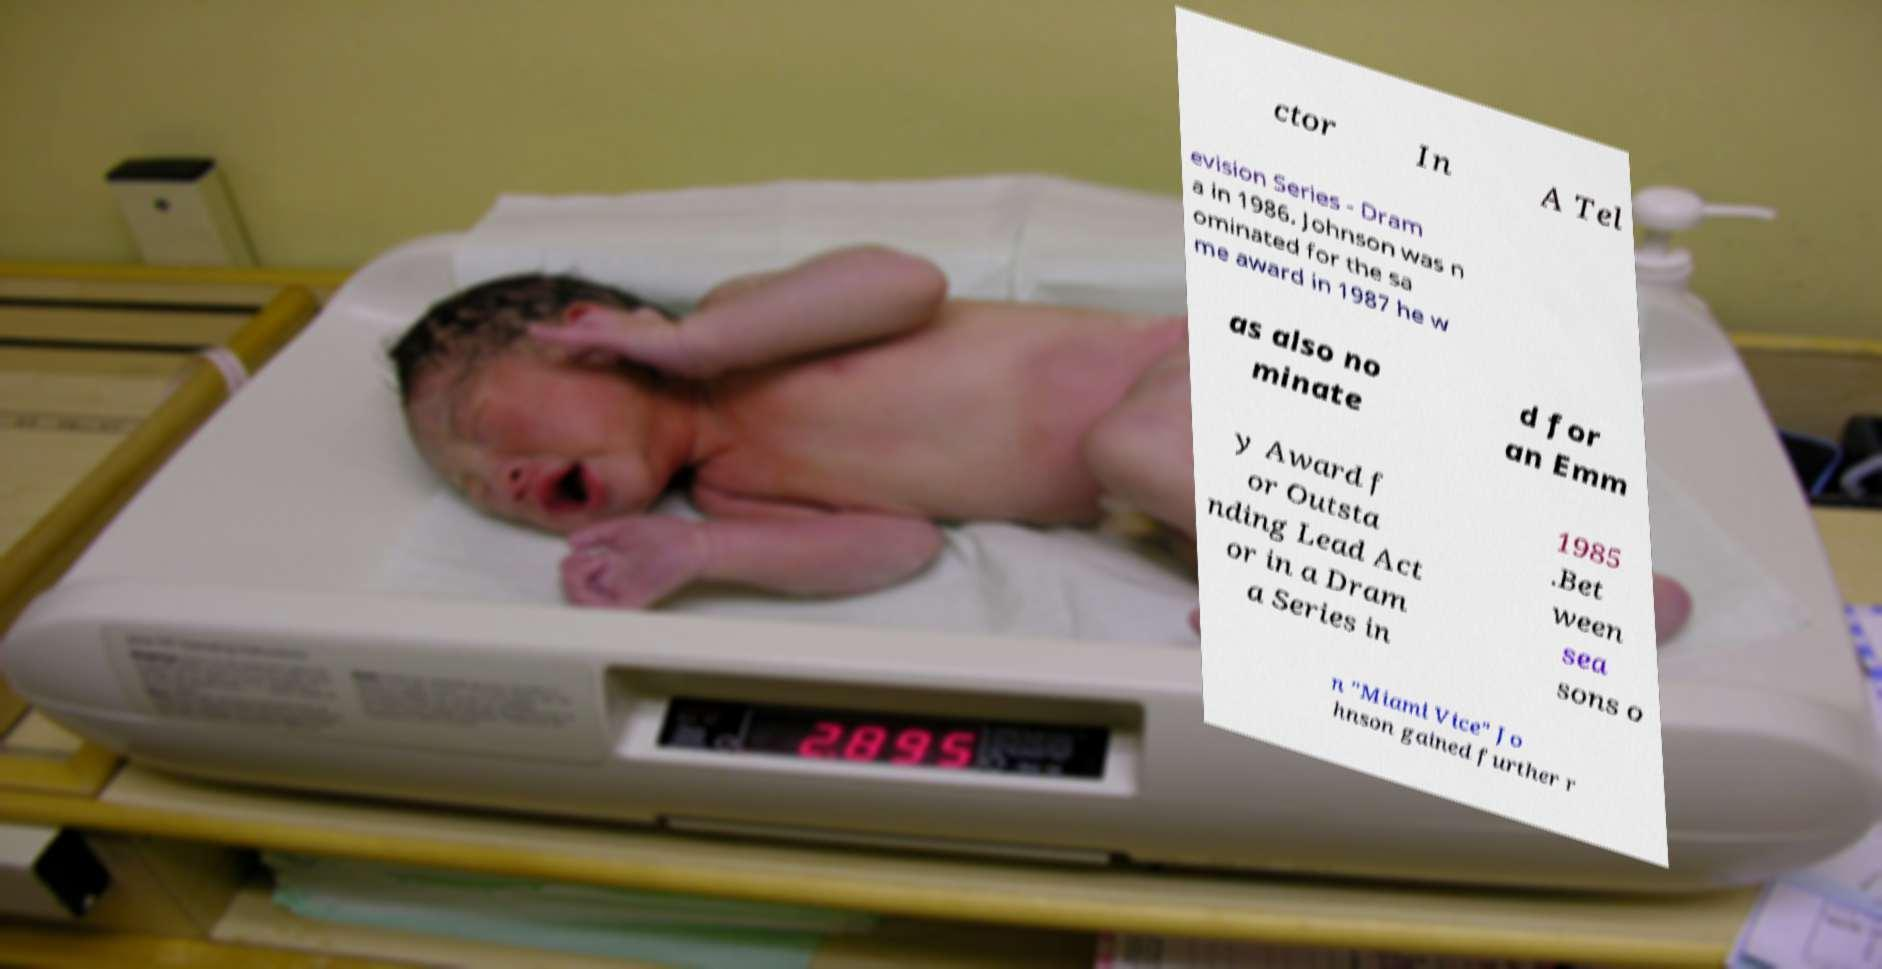Please identify and transcribe the text found in this image. ctor In A Tel evision Series - Dram a in 1986. Johnson was n ominated for the sa me award in 1987 he w as also no minate d for an Emm y Award f or Outsta nding Lead Act or in a Dram a Series in 1985 .Bet ween sea sons o n "Miami Vice" Jo hnson gained further r 